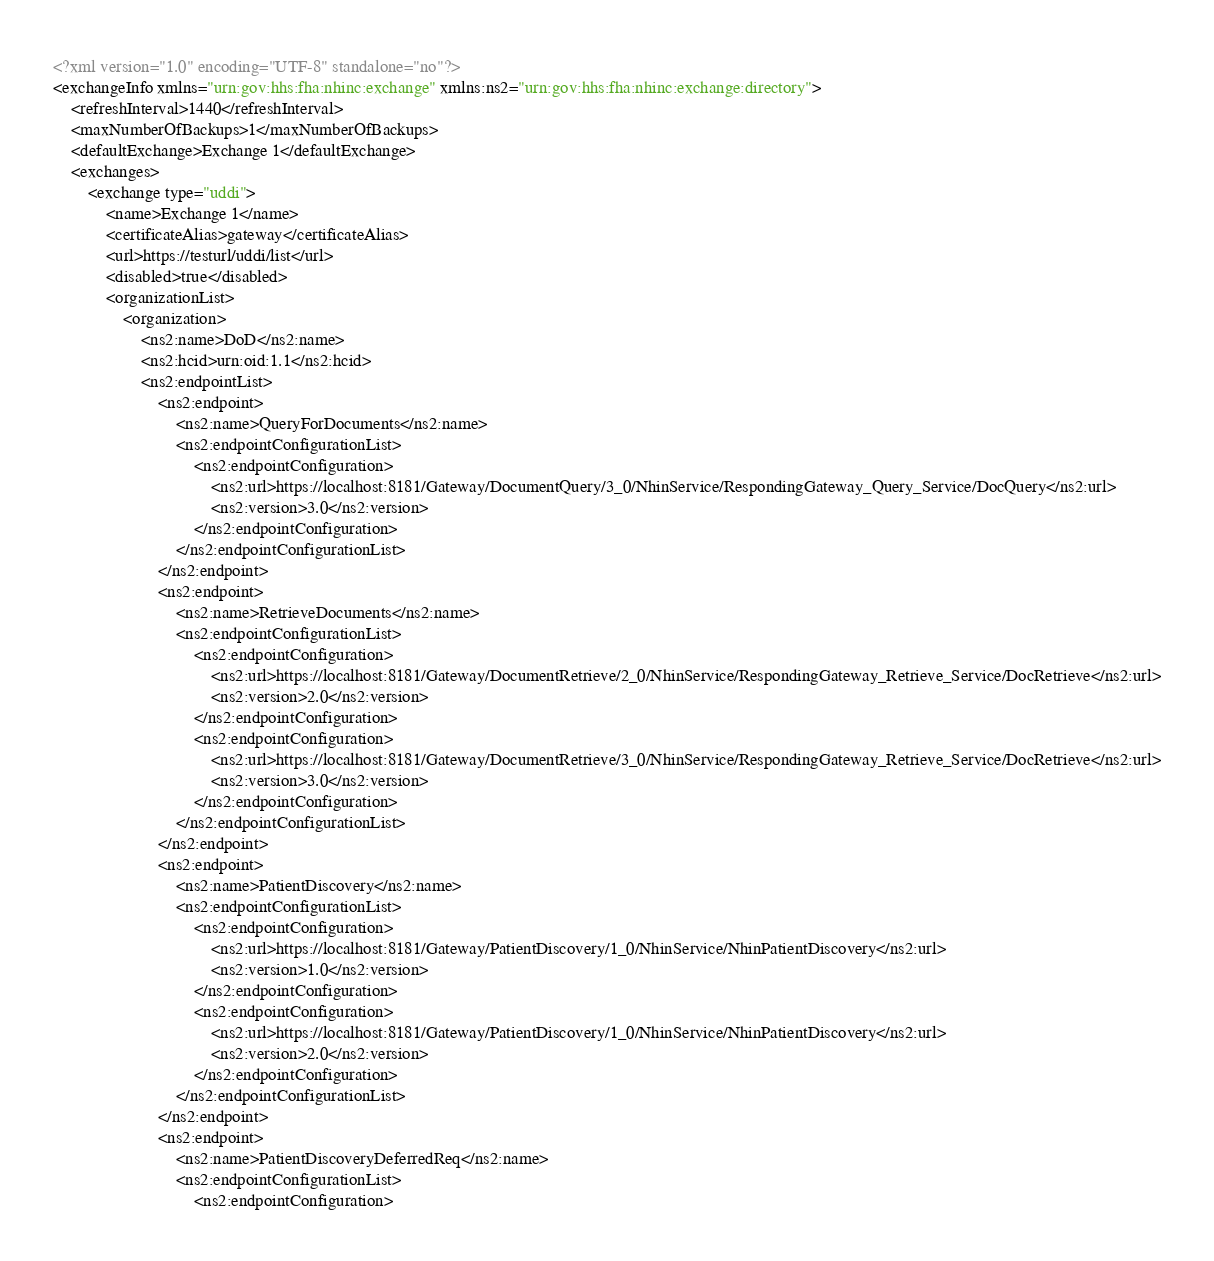<code> <loc_0><loc_0><loc_500><loc_500><_XML_><?xml version="1.0" encoding="UTF-8" standalone="no"?>
<exchangeInfo xmlns="urn:gov:hhs:fha:nhinc:exchange" xmlns:ns2="urn:gov:hhs:fha:nhinc:exchange:directory">
    <refreshInterval>1440</refreshInterval>
    <maxNumberOfBackups>1</maxNumberOfBackups>
    <defaultExchange>Exchange 1</defaultExchange>
    <exchanges>
        <exchange type="uddi">
            <name>Exchange 1</name>
            <certificateAlias>gateway</certificateAlias>
            <url>https://testurl/uddi/list</url>
            <disabled>true</disabled>
            <organizationList>
                <organization>
                    <ns2:name>DoD</ns2:name>
                    <ns2:hcid>urn:oid:1.1</ns2:hcid>
                    <ns2:endpointList>
                        <ns2:endpoint>
                            <ns2:name>QueryForDocuments</ns2:name>
                            <ns2:endpointConfigurationList>
                                <ns2:endpointConfiguration>
                                    <ns2:url>https://localhost:8181/Gateway/DocumentQuery/3_0/NhinService/RespondingGateway_Query_Service/DocQuery</ns2:url>
                                    <ns2:version>3.0</ns2:version>
                                </ns2:endpointConfiguration>
                            </ns2:endpointConfigurationList>
                        </ns2:endpoint>
                        <ns2:endpoint>
                            <ns2:name>RetrieveDocuments</ns2:name>
                            <ns2:endpointConfigurationList>
                                <ns2:endpointConfiguration>
                                    <ns2:url>https://localhost:8181/Gateway/DocumentRetrieve/2_0/NhinService/RespondingGateway_Retrieve_Service/DocRetrieve</ns2:url>
                                    <ns2:version>2.0</ns2:version>
                                </ns2:endpointConfiguration>
                                <ns2:endpointConfiguration>
                                    <ns2:url>https://localhost:8181/Gateway/DocumentRetrieve/3_0/NhinService/RespondingGateway_Retrieve_Service/DocRetrieve</ns2:url>
                                    <ns2:version>3.0</ns2:version>
                                </ns2:endpointConfiguration>
                            </ns2:endpointConfigurationList>
                        </ns2:endpoint>
                        <ns2:endpoint>
                            <ns2:name>PatientDiscovery</ns2:name>
                            <ns2:endpointConfigurationList>
                                <ns2:endpointConfiguration>
                                    <ns2:url>https://localhost:8181/Gateway/PatientDiscovery/1_0/NhinService/NhinPatientDiscovery</ns2:url>
                                    <ns2:version>1.0</ns2:version>
                                </ns2:endpointConfiguration>
                                <ns2:endpointConfiguration>
                                    <ns2:url>https://localhost:8181/Gateway/PatientDiscovery/1_0/NhinService/NhinPatientDiscovery</ns2:url>
                                    <ns2:version>2.0</ns2:version>
                                </ns2:endpointConfiguration>
                            </ns2:endpointConfigurationList>
                        </ns2:endpoint>
                        <ns2:endpoint>
                            <ns2:name>PatientDiscoveryDeferredReq</ns2:name>
                            <ns2:endpointConfigurationList>
                                <ns2:endpointConfiguration></code> 